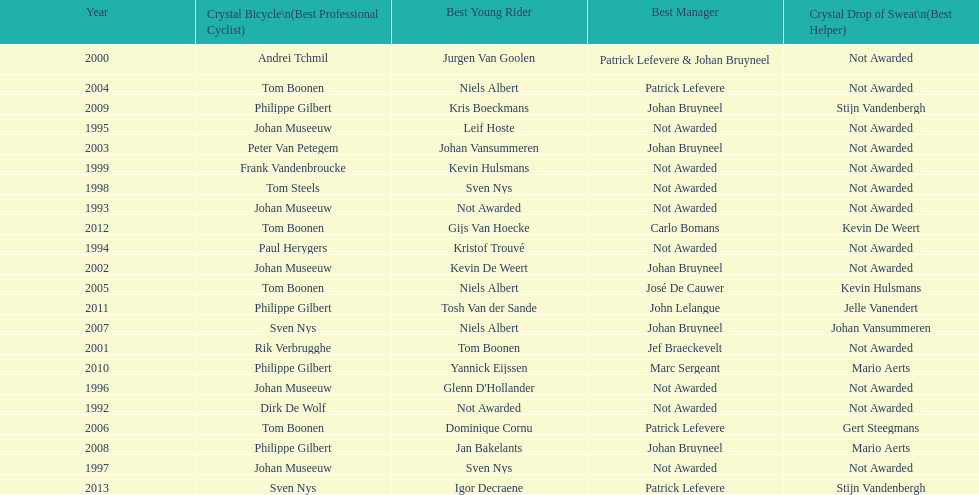Who won the crystal bicycle earlier, boonen or nys? Tom Boonen. 